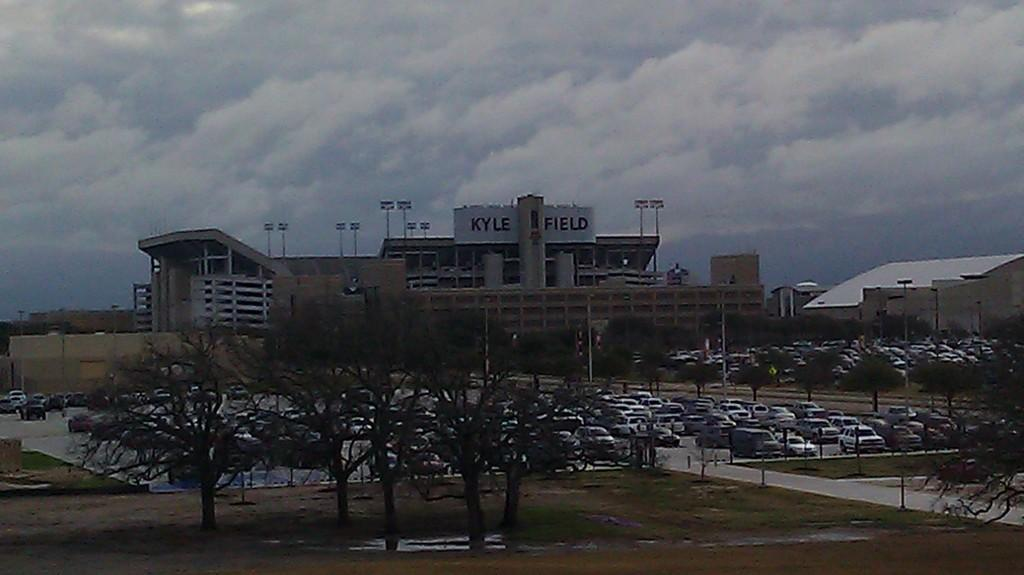What type of vegetation is present at the bottom of the image? There are trees at the bottom of the image. What can be seen in the middle of the image? There are many parked vehicles in the middle of the image. What type of structure is visible in the image? There is a big building in the image. What is visible at the top of the image? The sky is cloudy and visible at the top of the image. What type of attention is the building receiving in the image? The image does not convey any information about the building receiving attention; it simply shows the building's presence. Is there a border visible in the image? There is no mention of a border in the provided facts, and therefore it cannot be determined if one is present in the image. 